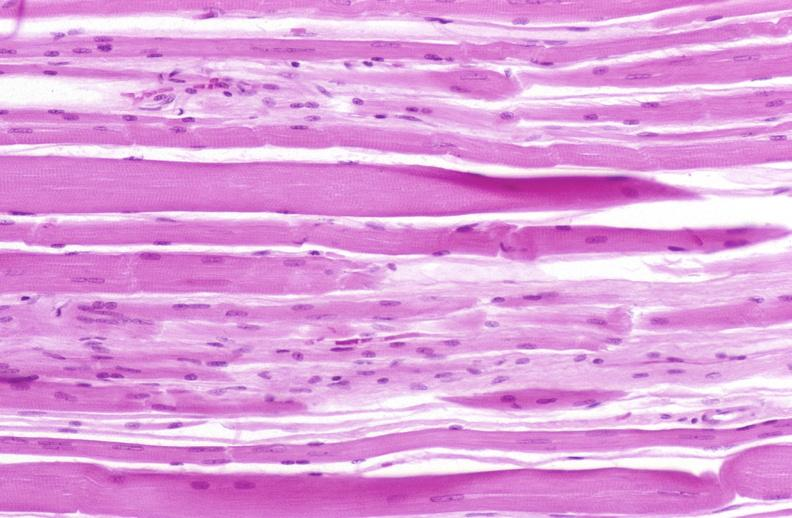what does this image show?
Answer the question using a single word or phrase. Skeletal muscle atrophy 